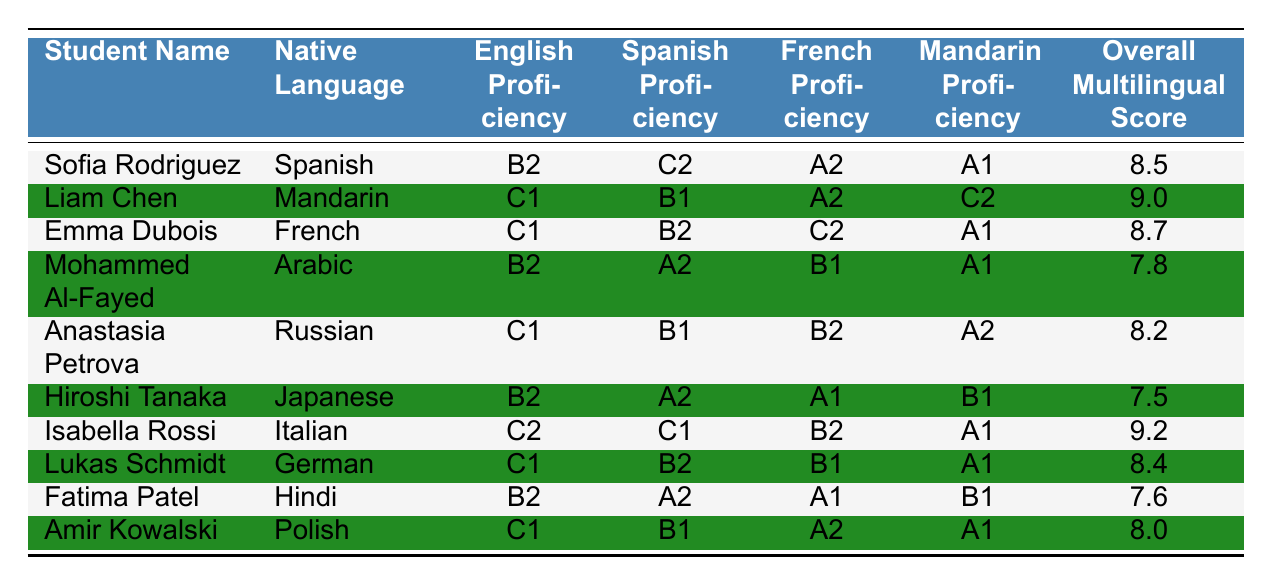What is the overall multilingual score of Isabella Rossi? The score is given in the table, specifically in the last column for Isabella Rossi’s entry. Looking under "Overall Multilingual Score," it shows a value of 9.2.
Answer: 9.2 How many languages is Sofia Rodriguez proficient in? In the table, Sofia Rodriguez has proficiency listed in four languages: English, Spanish, French, and Mandarin. Thus, she is proficient in four languages.
Answer: 4 Who has the highest English proficiency among the students? By scanning the "English Proficiency" column in the table, we identify the highest level, which is "C2" indicated for Isabella Rossi.
Answer: Isabella Rossi What is the average overall multilingual score of all students? The scores listed in the "Overall Multilingual Score" column are: 8.5, 9.0, 8.7, 7.8, 8.2, 7.5, 9.2, 8.4, 7.6, and 8.0. To calculate the average, we sum these values (8.5 + 9.0 + 8.7 + 7.8 + 8.2 + 7.5 + 9.2 + 8.4 + 7.6 + 8.0 = 87.9) and divide by the number of students (10), yielding an average of 8.79.
Answer: 8.79 Do any students have the same overall multilingual score? To check for duplicates, we compare the overall multilingual scores: 8.5, 9.0, 8.7, 7.8, 8.2, 7.5, 9.2, 8.4, 7.6, 8.0. All scores are unique; thus, no students share the same score.
Answer: No Which student has the lowest proficiency in Mandarin? By examining the "Mandarin Proficiency" column, we see A1 listed for both Sofia Rodriguez and Mohammed Al-Fayed, indicating they both have the lowest proficiency level.
Answer: Sofia Rodriguez and Mohammed Al-Fayed Is there a student who is proficient in all four languages listed? Looking through each student’s proficiency levels across all languages in the table, there is no student with proficiency in all four languages; the highest are those proficient in three languages.
Answer: No What is the difference between the highest and lowest overall multilingual scores? From the scores, the highest is 9.2 (Isabella Rossi) and the lowest is 7.5 (Hiroshi Tanaka). The difference is calculated as 9.2 - 7.5 = 1.7.
Answer: 1.7 Which student has C1 proficiency in Mandarin? Reviewing the "Mandarin Proficiency" column, Liam Chen is the only student with a C1 rating in Mandarin, as indicated in his respective row.
Answer: Liam Chen Are there more students with a proficiency level of C1 than A1? Counting the students, we see 5 students have C1 proficiency (Liam Chen, Emma Dubois, Anastasia Petrova, Isabella Rossi, Lukas Schmidt) while 4 students have A1 proficiency (Sofia Rodriguez, Hiroshi Tanaka, Fatima Patel, Amir Kowalski). Therefore, C1 has more students than A1.
Answer: Yes 